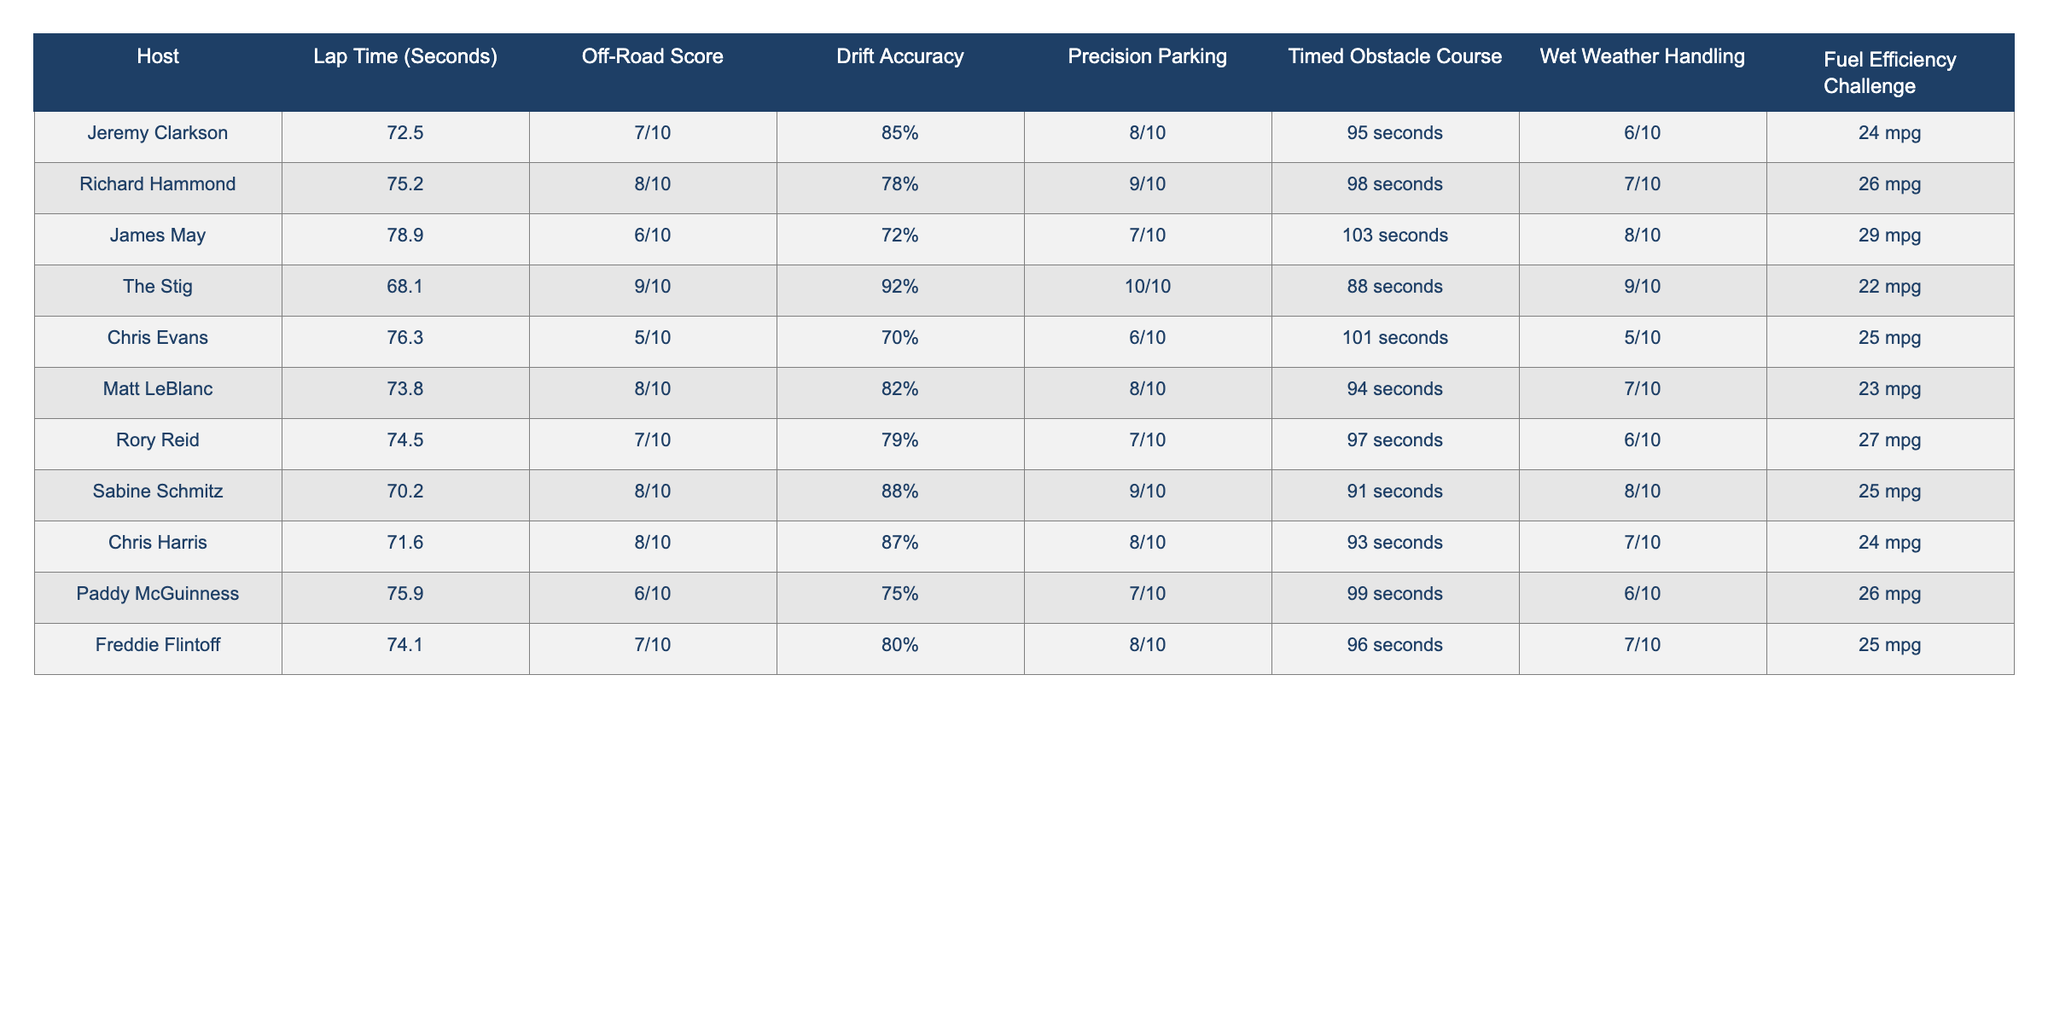What is the lap time of The Stig? The lap time of The Stig is listed in the table as 68.1 seconds.
Answer: 68.1 seconds Who has the highest off-road score? The highest off-road score in the table is 9/10, which belongs to The Stig.
Answer: The Stig What is the average drift accuracy among all hosts? To find the average drift accuracy, convert the percentages to decimals: (0.85 + 0.78 + 0.72 + 0.92 + 0.70 + 0.82 + 0.79 + 0.88 + 0.87 + 0.75 + 0.80) / 11 = 0.79, which is approximately 79%.
Answer: 79% Is James May's wet weather handling better than Chris Evans'? James May has a wet weather handling score of 8/10, while Chris Evans has 5/10. Since 8 is greater than 5, yes, James May's score is better.
Answer: Yes Which host took the longest to complete the timed obstacle course and what was their time? James May completed the timed obstacle course in 103 seconds, which is the longest time listed in the table.
Answer: 103 seconds How much better is The Stig's lap time compared to Chris Evans'? The difference in lap times is calculated by subtracting Chris Evans' lap time (76.3 seconds) from The Stig's lap time (68.1 seconds). 76.3 - 68.1 = 8.2 seconds, meaning The Stig is 8.2 seconds faster.
Answer: 8.2 seconds What percentage of the driving hosts scored 7/10 or higher in fuel efficiency? The hosts with 7/10 or higher fuel efficiency are Richard Hammond, James May, Rory Reid, and Freddie Flintoff, making it four out of eleven hosts. Therefore, (4/11) * 100 = approximately 36.36%.
Answer: 36.36% Who scored the lowest in the drift accuracy challenge? Chris Evans has the lowest drift accuracy score at 70%.
Answer: Chris Evans What is the total off-road score of all hosts combined? Convert the off-road scores from fractional form to numbers: (7 + 8 + 6 + 9 + 5 + 8 + 7 + 8 + 8 + 6 + 7) = 8 + 6 + 9 = 82. Divide that sum by 11 (the number of hosts) to find the average. The total is simply the sum which is 82, but noting that it's an aggregate is equally valid.
Answer: 82 Is there any host who achieved 10/10 in precision parking? The only host who achieved a score of 10/10 in precision parking is The Stig. Thus, the answer is true.
Answer: Yes 